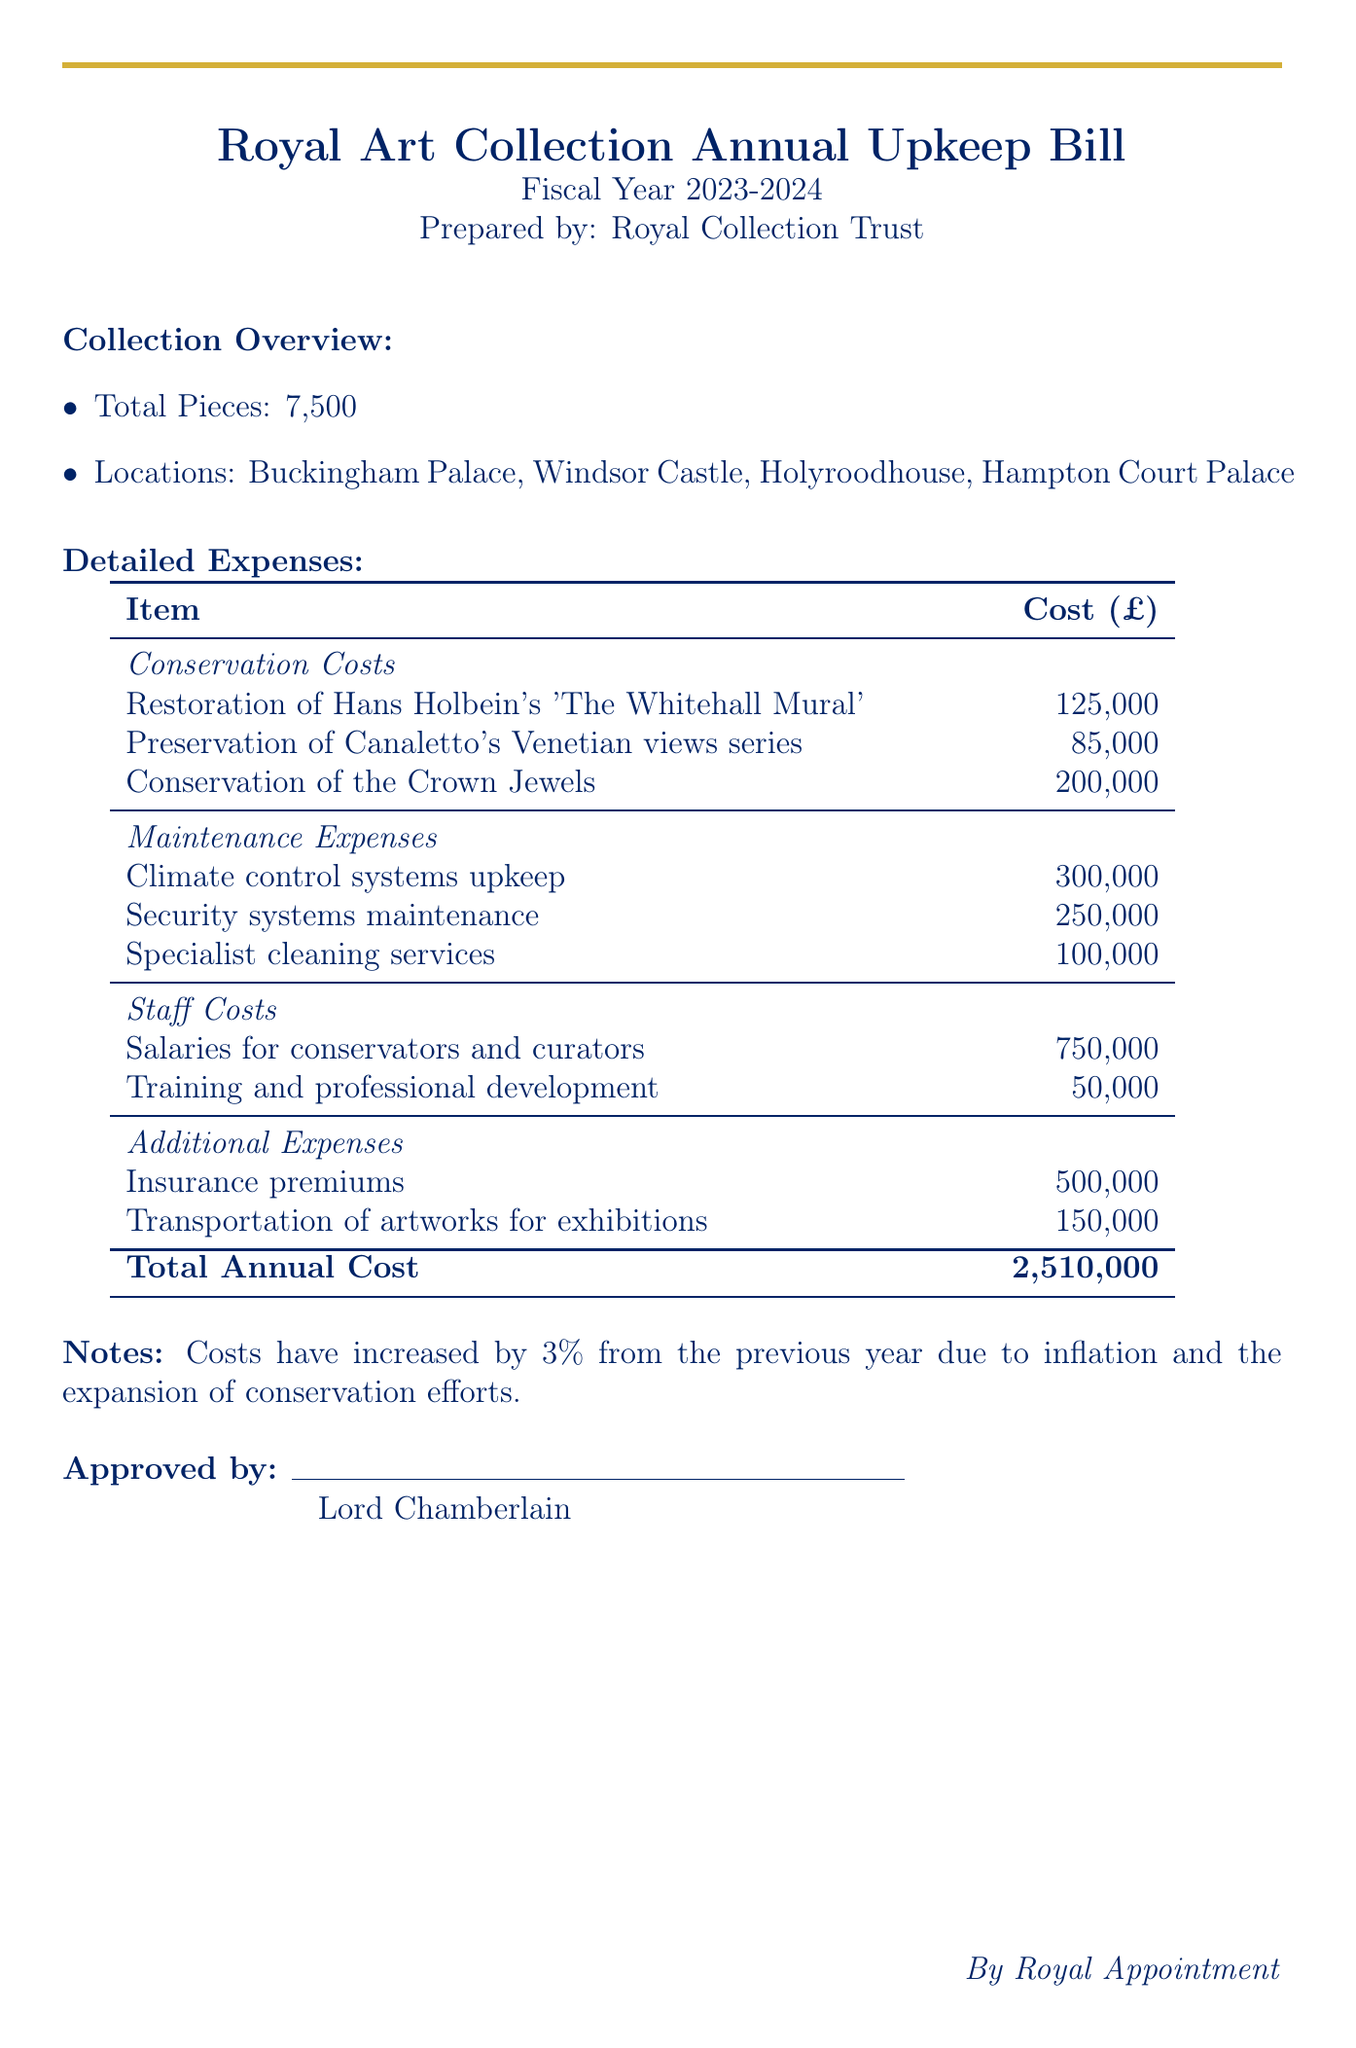What is the total number of pieces in the collection? The total number of pieces is stated in the document under the Collection Overview section.
Answer: 7,500 What is the cost for the restoration of 'The Whitehall Mural'? The cost is listed under the Conservation Costs in the Detailed Expenses section.
Answer: 125,000 Who prepared the bill? The name of the preparer is mentioned at the top of the document.
Answer: Royal Collection Trust What is the total annual cost for the upkeep? The total annual cost is provided at the bottom of the Detailed Expenses table.
Answer: 2,510,000 How much is allocated for security systems maintenance? This amount is specified under the Maintenance Expenses in the Detailed Expenses section.
Answer: 250,000 Which artwork is listed as having the highest conservation cost? This information can be obtained from the Conservation Costs section in the Detailed Expenses.
Answer: Crown Jewels What percent have costs increased from the previous year? This information is noted in the Notes section towards the end of the document.
Answer: 3% Who is the document approved by? The approver is mentioned at the end of the document.
Answer: Lord Chamberlain 